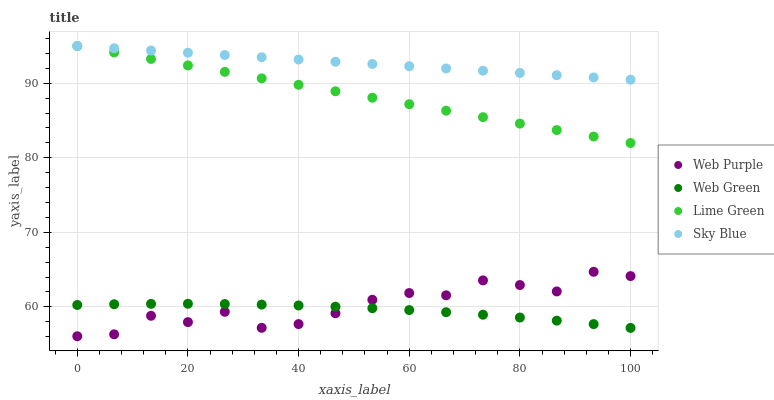Does Web Green have the minimum area under the curve?
Answer yes or no. Yes. Does Sky Blue have the maximum area under the curve?
Answer yes or no. Yes. Does Web Purple have the minimum area under the curve?
Answer yes or no. No. Does Web Purple have the maximum area under the curve?
Answer yes or no. No. Is Lime Green the smoothest?
Answer yes or no. Yes. Is Web Purple the roughest?
Answer yes or no. Yes. Is Web Purple the smoothest?
Answer yes or no. No. Is Lime Green the roughest?
Answer yes or no. No. Does Web Purple have the lowest value?
Answer yes or no. Yes. Does Lime Green have the lowest value?
Answer yes or no. No. Does Lime Green have the highest value?
Answer yes or no. Yes. Does Web Purple have the highest value?
Answer yes or no. No. Is Web Purple less than Lime Green?
Answer yes or no. Yes. Is Lime Green greater than Web Purple?
Answer yes or no. Yes. Does Web Purple intersect Web Green?
Answer yes or no. Yes. Is Web Purple less than Web Green?
Answer yes or no. No. Is Web Purple greater than Web Green?
Answer yes or no. No. Does Web Purple intersect Lime Green?
Answer yes or no. No. 